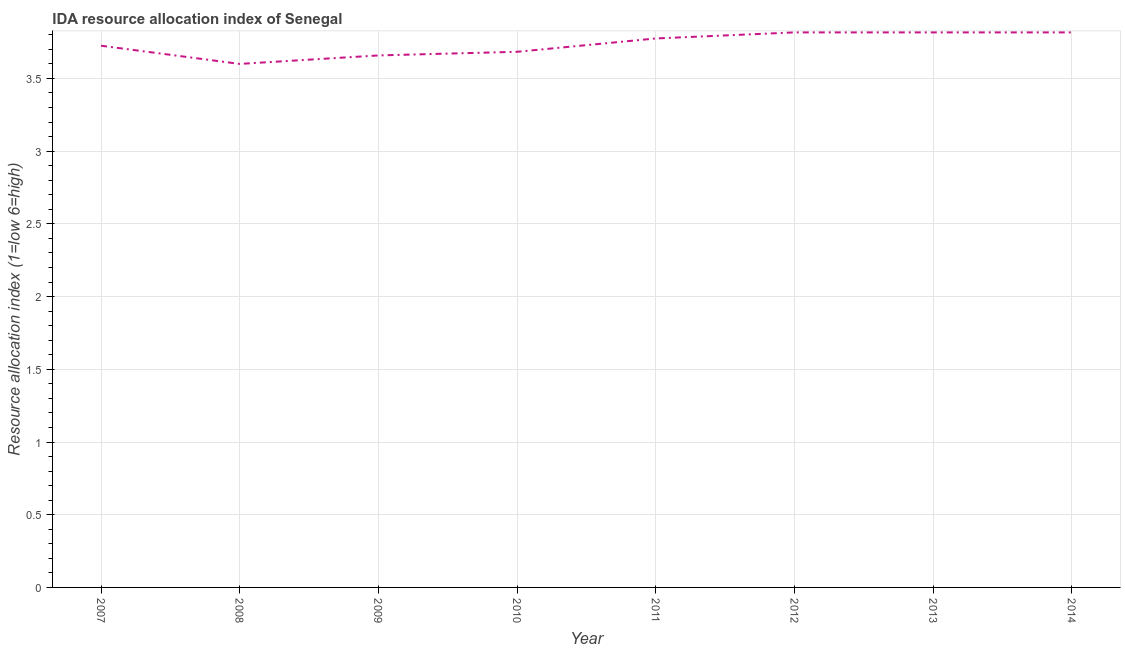What is the ida resource allocation index in 2013?
Provide a succinct answer. 3.82. Across all years, what is the maximum ida resource allocation index?
Offer a terse response. 3.82. What is the sum of the ida resource allocation index?
Keep it short and to the point. 29.89. What is the difference between the ida resource allocation index in 2009 and 2012?
Provide a short and direct response. -0.16. What is the average ida resource allocation index per year?
Give a very brief answer. 3.74. What is the median ida resource allocation index?
Keep it short and to the point. 3.75. In how many years, is the ida resource allocation index greater than 2.2 ?
Your answer should be compact. 8. What is the ratio of the ida resource allocation index in 2007 to that in 2009?
Your response must be concise. 1.02. What is the difference between the highest and the lowest ida resource allocation index?
Your answer should be very brief. 0.22. In how many years, is the ida resource allocation index greater than the average ida resource allocation index taken over all years?
Your response must be concise. 4. How many lines are there?
Ensure brevity in your answer.  1. Does the graph contain any zero values?
Your answer should be compact. No. Does the graph contain grids?
Make the answer very short. Yes. What is the title of the graph?
Ensure brevity in your answer.  IDA resource allocation index of Senegal. What is the label or title of the Y-axis?
Ensure brevity in your answer.  Resource allocation index (1=low 6=high). What is the Resource allocation index (1=low 6=high) of 2007?
Your answer should be very brief. 3.73. What is the Resource allocation index (1=low 6=high) of 2008?
Provide a short and direct response. 3.6. What is the Resource allocation index (1=low 6=high) of 2009?
Your answer should be compact. 3.66. What is the Resource allocation index (1=low 6=high) in 2010?
Ensure brevity in your answer.  3.68. What is the Resource allocation index (1=low 6=high) in 2011?
Your answer should be very brief. 3.77. What is the Resource allocation index (1=low 6=high) of 2012?
Make the answer very short. 3.82. What is the Resource allocation index (1=low 6=high) of 2013?
Your answer should be compact. 3.82. What is the Resource allocation index (1=low 6=high) of 2014?
Offer a very short reply. 3.82. What is the difference between the Resource allocation index (1=low 6=high) in 2007 and 2009?
Your answer should be compact. 0.07. What is the difference between the Resource allocation index (1=low 6=high) in 2007 and 2010?
Your answer should be very brief. 0.04. What is the difference between the Resource allocation index (1=low 6=high) in 2007 and 2012?
Your response must be concise. -0.09. What is the difference between the Resource allocation index (1=low 6=high) in 2007 and 2013?
Give a very brief answer. -0.09. What is the difference between the Resource allocation index (1=low 6=high) in 2007 and 2014?
Your answer should be very brief. -0.09. What is the difference between the Resource allocation index (1=low 6=high) in 2008 and 2009?
Keep it short and to the point. -0.06. What is the difference between the Resource allocation index (1=low 6=high) in 2008 and 2010?
Offer a very short reply. -0.08. What is the difference between the Resource allocation index (1=low 6=high) in 2008 and 2011?
Provide a succinct answer. -0.17. What is the difference between the Resource allocation index (1=low 6=high) in 2008 and 2012?
Ensure brevity in your answer.  -0.22. What is the difference between the Resource allocation index (1=low 6=high) in 2008 and 2013?
Give a very brief answer. -0.22. What is the difference between the Resource allocation index (1=low 6=high) in 2008 and 2014?
Give a very brief answer. -0.22. What is the difference between the Resource allocation index (1=low 6=high) in 2009 and 2010?
Ensure brevity in your answer.  -0.03. What is the difference between the Resource allocation index (1=low 6=high) in 2009 and 2011?
Offer a terse response. -0.12. What is the difference between the Resource allocation index (1=low 6=high) in 2009 and 2012?
Make the answer very short. -0.16. What is the difference between the Resource allocation index (1=low 6=high) in 2009 and 2013?
Ensure brevity in your answer.  -0.16. What is the difference between the Resource allocation index (1=low 6=high) in 2009 and 2014?
Your answer should be compact. -0.16. What is the difference between the Resource allocation index (1=low 6=high) in 2010 and 2011?
Offer a terse response. -0.09. What is the difference between the Resource allocation index (1=low 6=high) in 2010 and 2012?
Your answer should be very brief. -0.13. What is the difference between the Resource allocation index (1=low 6=high) in 2010 and 2013?
Ensure brevity in your answer.  -0.13. What is the difference between the Resource allocation index (1=low 6=high) in 2010 and 2014?
Give a very brief answer. -0.13. What is the difference between the Resource allocation index (1=low 6=high) in 2011 and 2012?
Offer a very short reply. -0.04. What is the difference between the Resource allocation index (1=low 6=high) in 2011 and 2013?
Your response must be concise. -0.04. What is the difference between the Resource allocation index (1=low 6=high) in 2011 and 2014?
Your answer should be very brief. -0.04. What is the difference between the Resource allocation index (1=low 6=high) in 2012 and 2013?
Offer a very short reply. 0. What is the difference between the Resource allocation index (1=low 6=high) in 2012 and 2014?
Ensure brevity in your answer.  0. What is the difference between the Resource allocation index (1=low 6=high) in 2013 and 2014?
Your answer should be compact. 0. What is the ratio of the Resource allocation index (1=low 6=high) in 2007 to that in 2008?
Keep it short and to the point. 1.03. What is the ratio of the Resource allocation index (1=low 6=high) in 2007 to that in 2010?
Your answer should be compact. 1.01. What is the ratio of the Resource allocation index (1=low 6=high) in 2007 to that in 2014?
Keep it short and to the point. 0.98. What is the ratio of the Resource allocation index (1=low 6=high) in 2008 to that in 2010?
Ensure brevity in your answer.  0.98. What is the ratio of the Resource allocation index (1=low 6=high) in 2008 to that in 2011?
Give a very brief answer. 0.95. What is the ratio of the Resource allocation index (1=low 6=high) in 2008 to that in 2012?
Make the answer very short. 0.94. What is the ratio of the Resource allocation index (1=low 6=high) in 2008 to that in 2013?
Keep it short and to the point. 0.94. What is the ratio of the Resource allocation index (1=low 6=high) in 2008 to that in 2014?
Your answer should be compact. 0.94. What is the ratio of the Resource allocation index (1=low 6=high) in 2009 to that in 2010?
Provide a short and direct response. 0.99. What is the ratio of the Resource allocation index (1=low 6=high) in 2009 to that in 2011?
Offer a very short reply. 0.97. What is the ratio of the Resource allocation index (1=low 6=high) in 2010 to that in 2012?
Provide a short and direct response. 0.96. What is the ratio of the Resource allocation index (1=low 6=high) in 2011 to that in 2013?
Offer a terse response. 0.99. What is the ratio of the Resource allocation index (1=low 6=high) in 2011 to that in 2014?
Offer a terse response. 0.99. What is the ratio of the Resource allocation index (1=low 6=high) in 2012 to that in 2013?
Keep it short and to the point. 1. What is the ratio of the Resource allocation index (1=low 6=high) in 2012 to that in 2014?
Your answer should be compact. 1. What is the ratio of the Resource allocation index (1=low 6=high) in 2013 to that in 2014?
Provide a short and direct response. 1. 